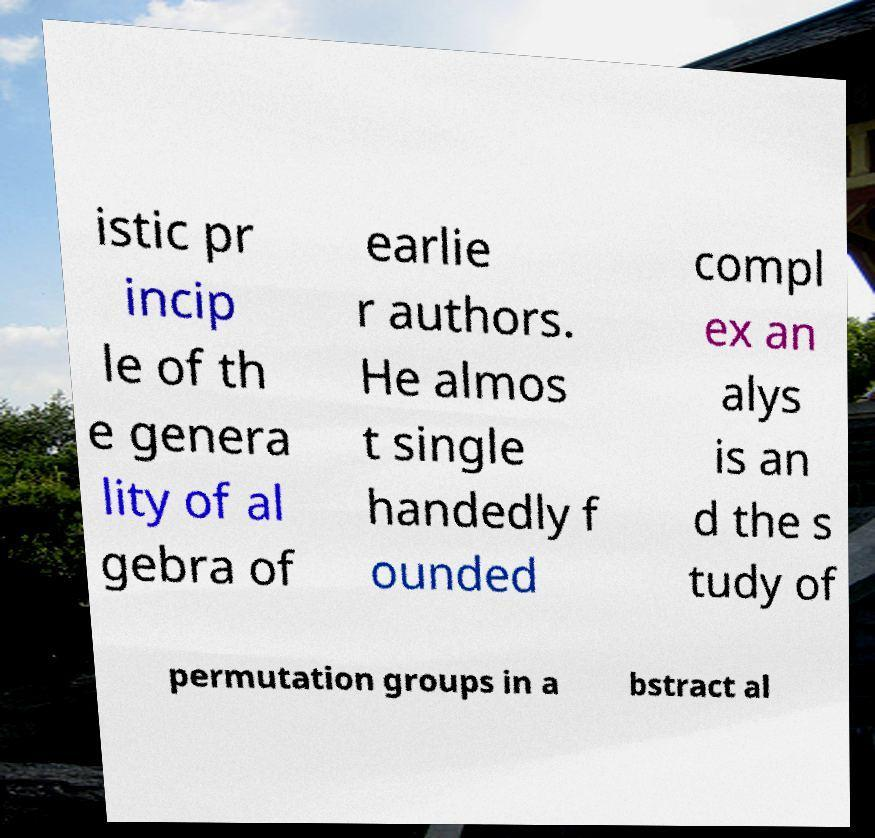There's text embedded in this image that I need extracted. Can you transcribe it verbatim? istic pr incip le of th e genera lity of al gebra of earlie r authors. He almos t single handedly f ounded compl ex an alys is an d the s tudy of permutation groups in a bstract al 